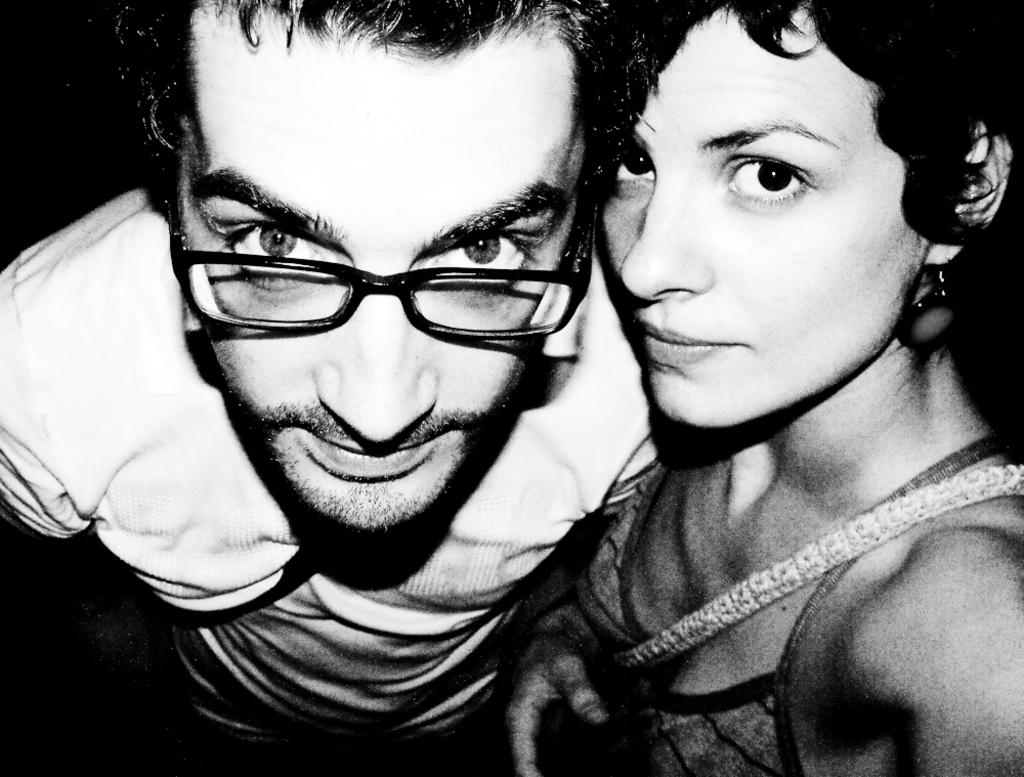What is the color scheme of the image? The image is black and white. How many people are in the image? There are two people standing in the image. Where are the people standing? The people are standing on a path. What can be seen behind the people in the image? There is a dark background in the image. Is there a beggar asking for money in the image? There is no beggar present in the image. What force is being applied to the people in the image? There is no force being applied to the people in the image; they are standing still. 